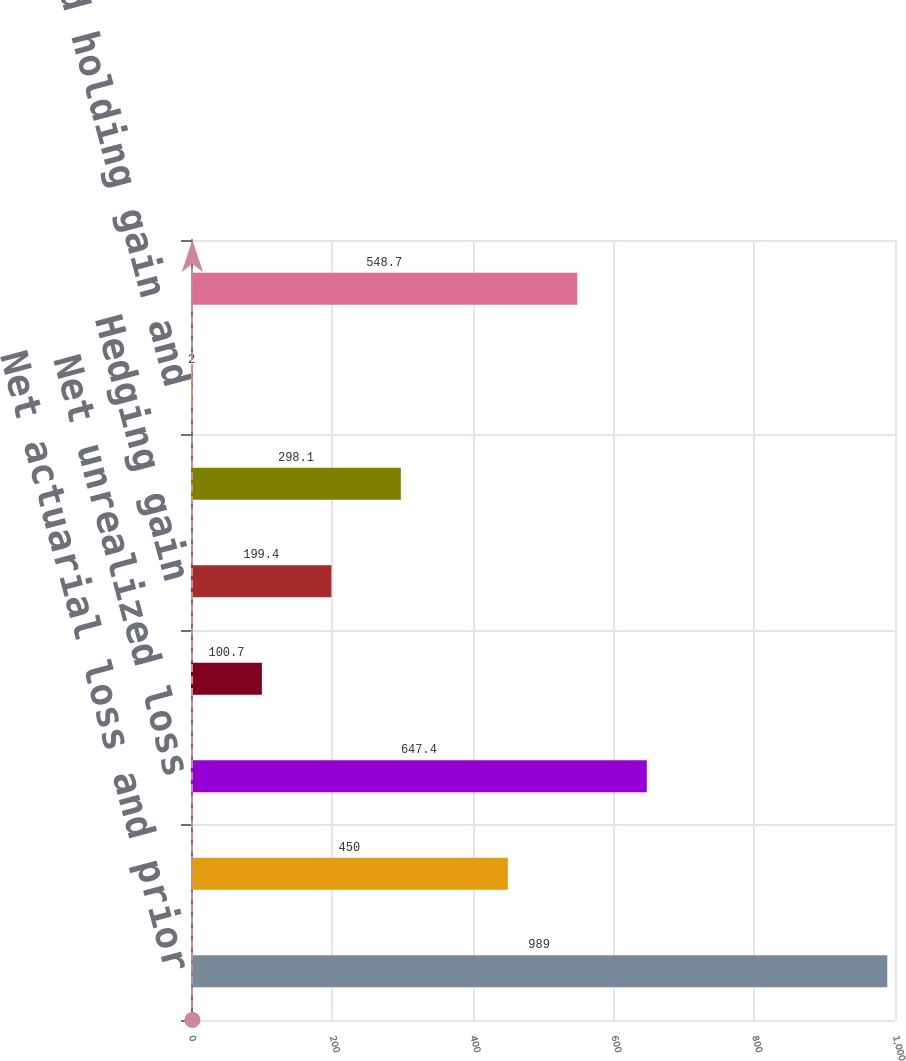Convert chart. <chart><loc_0><loc_0><loc_500><loc_500><bar_chart><fcel>Net actuarial loss and prior<fcel>Reclassification of actuarial<fcel>Net unrealized loss<fcel>Cumulative translation<fcel>Hedging gain<fcel>Net unrealized gain<fcel>Unrealized holding gain and<fcel>Total other comprehensive<nl><fcel>989<fcel>450<fcel>647.4<fcel>100.7<fcel>199.4<fcel>298.1<fcel>2<fcel>548.7<nl></chart> 